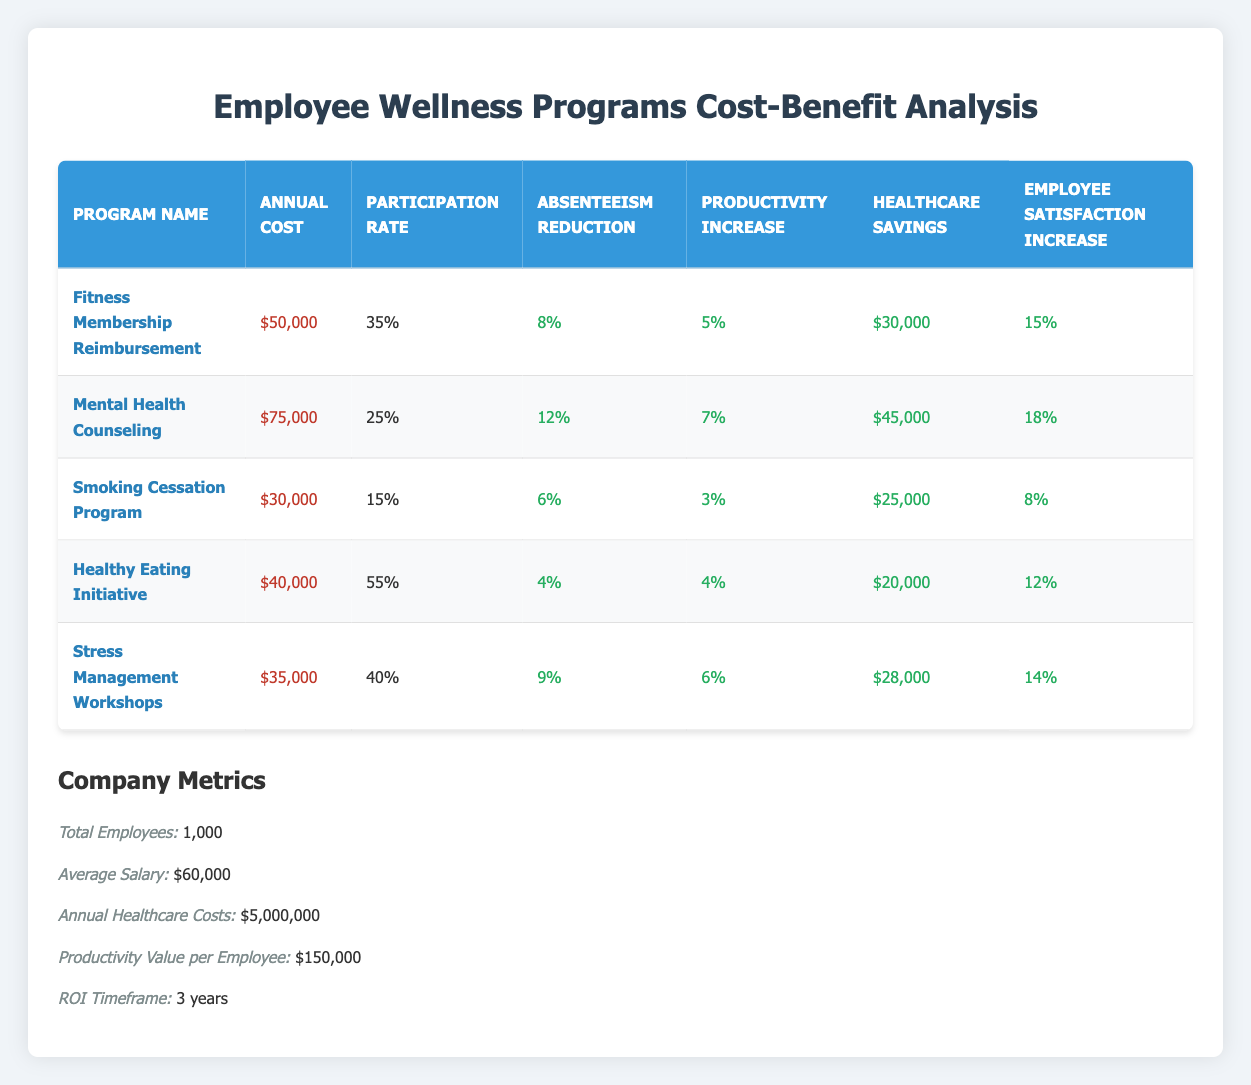What is the annual cost of the Fitness Membership Reimbursement program? The table explicitly lists the annual cost for each program. For the Fitness Membership Reimbursement program, it is stated directly under the "Annual Cost" column as $50,000.
Answer: $50,000 Which program has the highest participation rate? The participation rate is shown for each program. Upon comparing the values listed, the Healthy Eating Initiative has the highest participation rate at 55%.
Answer: 55% What is the total annual cost for all wellness programs combined? To find the total annual cost, sum the individual annual costs: $50,000 + $75,000 + $30,000 + $40,000 + $35,000 = $230,000.
Answer: $230,000 Is it true that the Smoking Cessation Program has the lowest healthcare savings? Looking at the "Healthcare Savings" column, we can see that the Smoking Cessation Program has $25,000 in savings, which is less than the other programs. Therefore, this statement is true.
Answer: Yes What is the average absenteeism reduction rate across all programs? First, sum the absenteeism reduction rates: 8% + 12% + 6% + 4% + 9% = 39%. Then, divide by the number of programs, which is 5: 39% / 5 = 7.8%.
Answer: 7.8% If a program has a productivity increase of 6%, which program is it? Checking the "Productivity Increase" column, we see that the Stress Management Workshops program has a productivity increase of 6%.
Answer: Stress Management Workshops Which program yields the highest increase in employee satisfaction? By comparing the "Employee Satisfaction Increase" column, the Mental Health Counseling program shows an increase of 18%, which is the highest among all programs.
Answer: 18% What is the combined absenteeism reduction for all programs? To calculate the combined absenteeism reduction, we add 8% + 12% + 6% + 4% + 9% = 39%.
Answer: 39% Are there any programs that have a cost lower than $40,000? By reviewing the "Annual Cost" column, we see that the Smoking Cessation Program costs $30,000 and the Stress Management Workshops cost $35,000, both lower than $40,000. Therefore, the statement is true.
Answer: Yes 